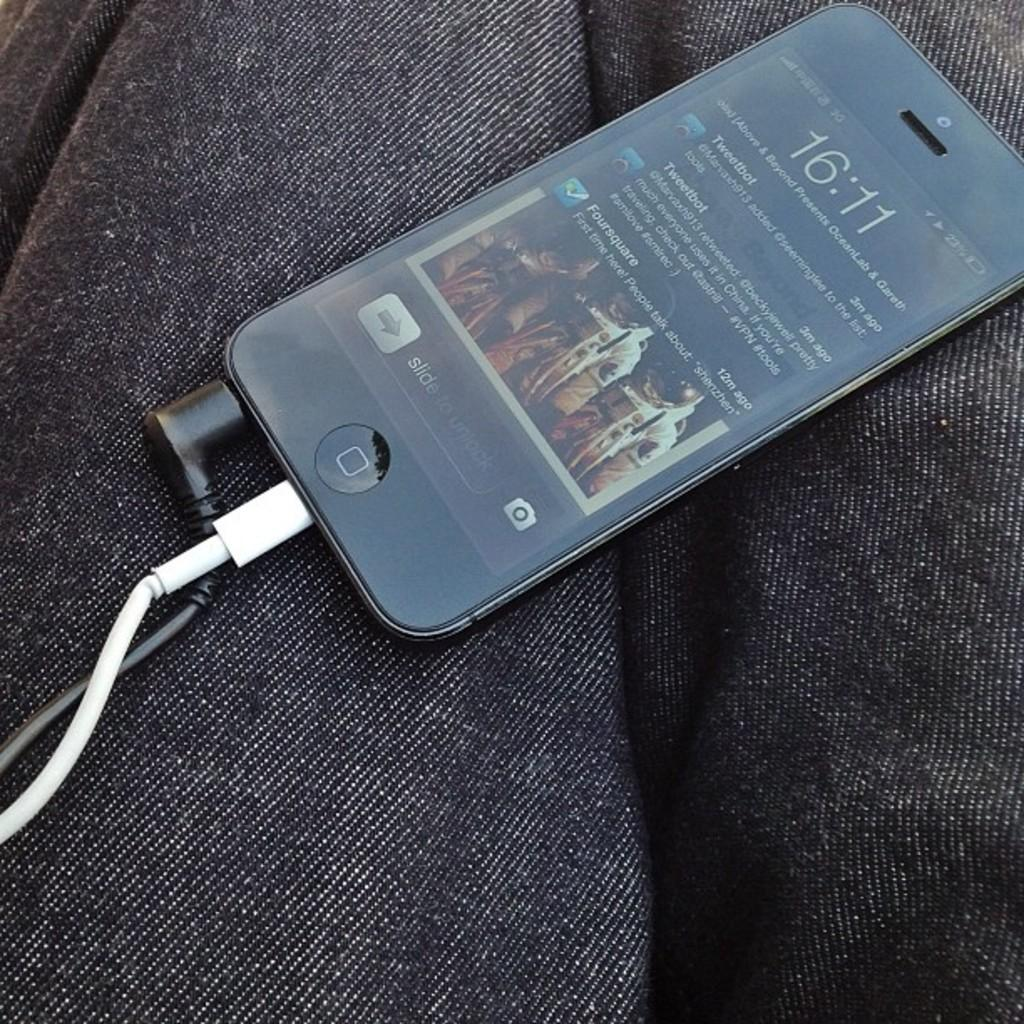What electronic device is visible in the image? There is a mobile phone in the image. What feature is present on the mobile phone? The mobile phone has wires. On what surface is the mobile phone placed? The mobile phone is placed on some cloth. How many pies are being shared between the partners in the image? There are no pies or partners present in the image; it only features a mobile phone with wires placed on some cloth. 